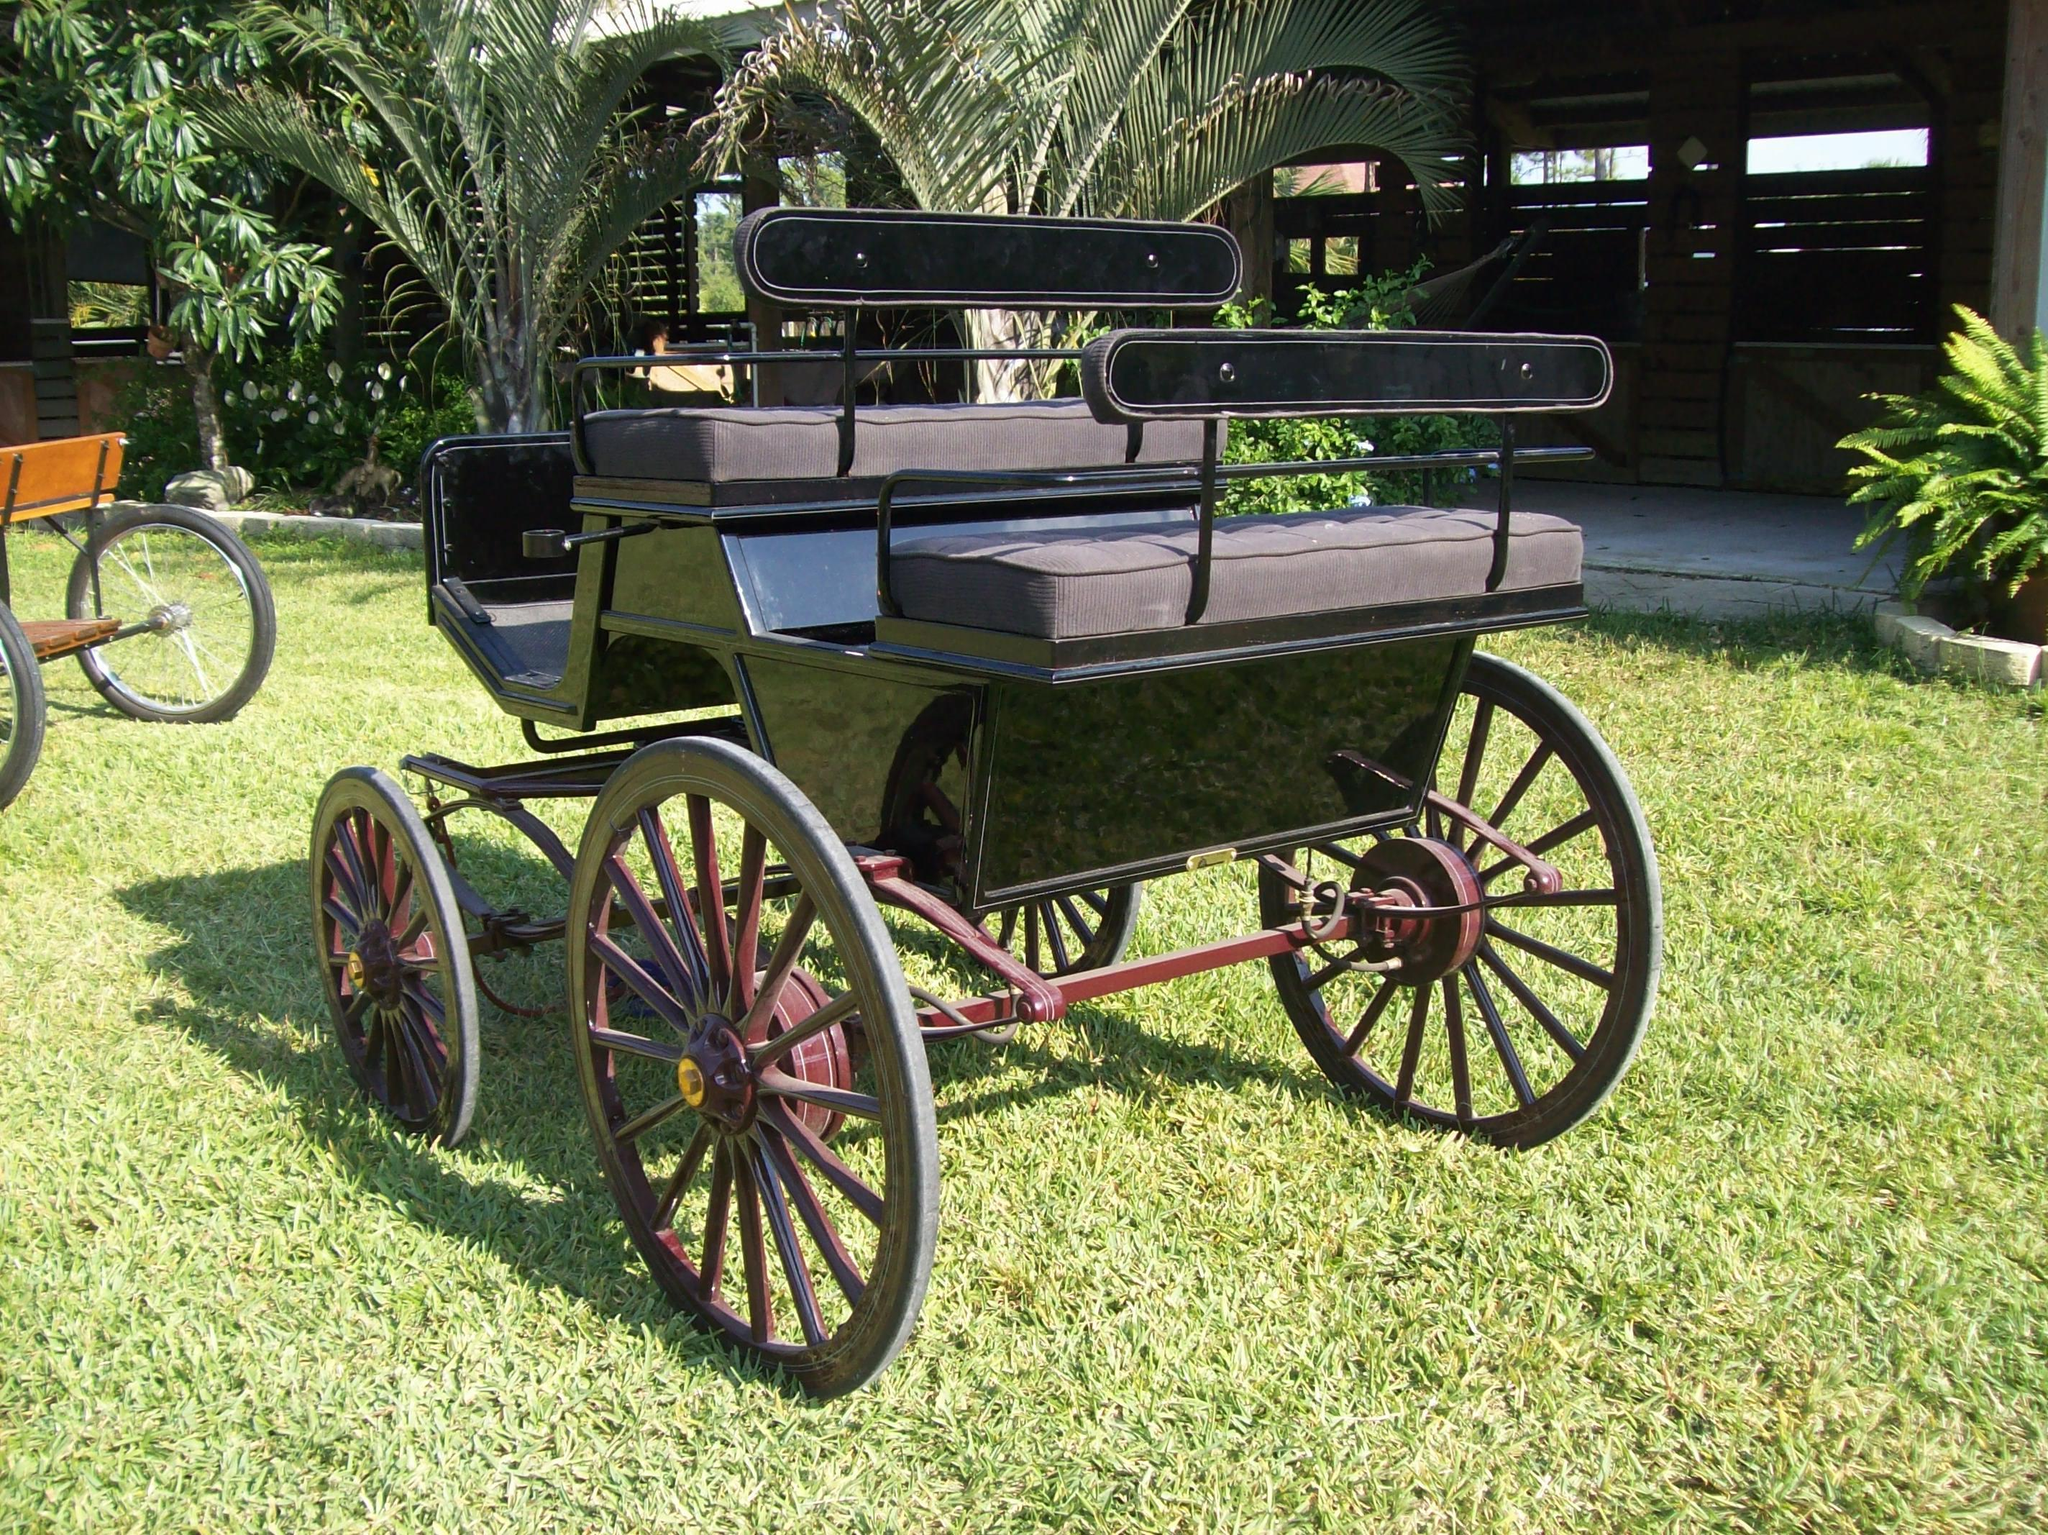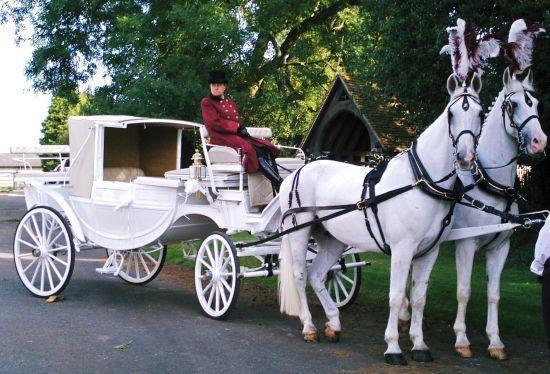The first image is the image on the left, the second image is the image on the right. Analyze the images presented: Is the assertion "An image shows a buggy with treaded rubber tires." valid? Answer yes or no. No. 